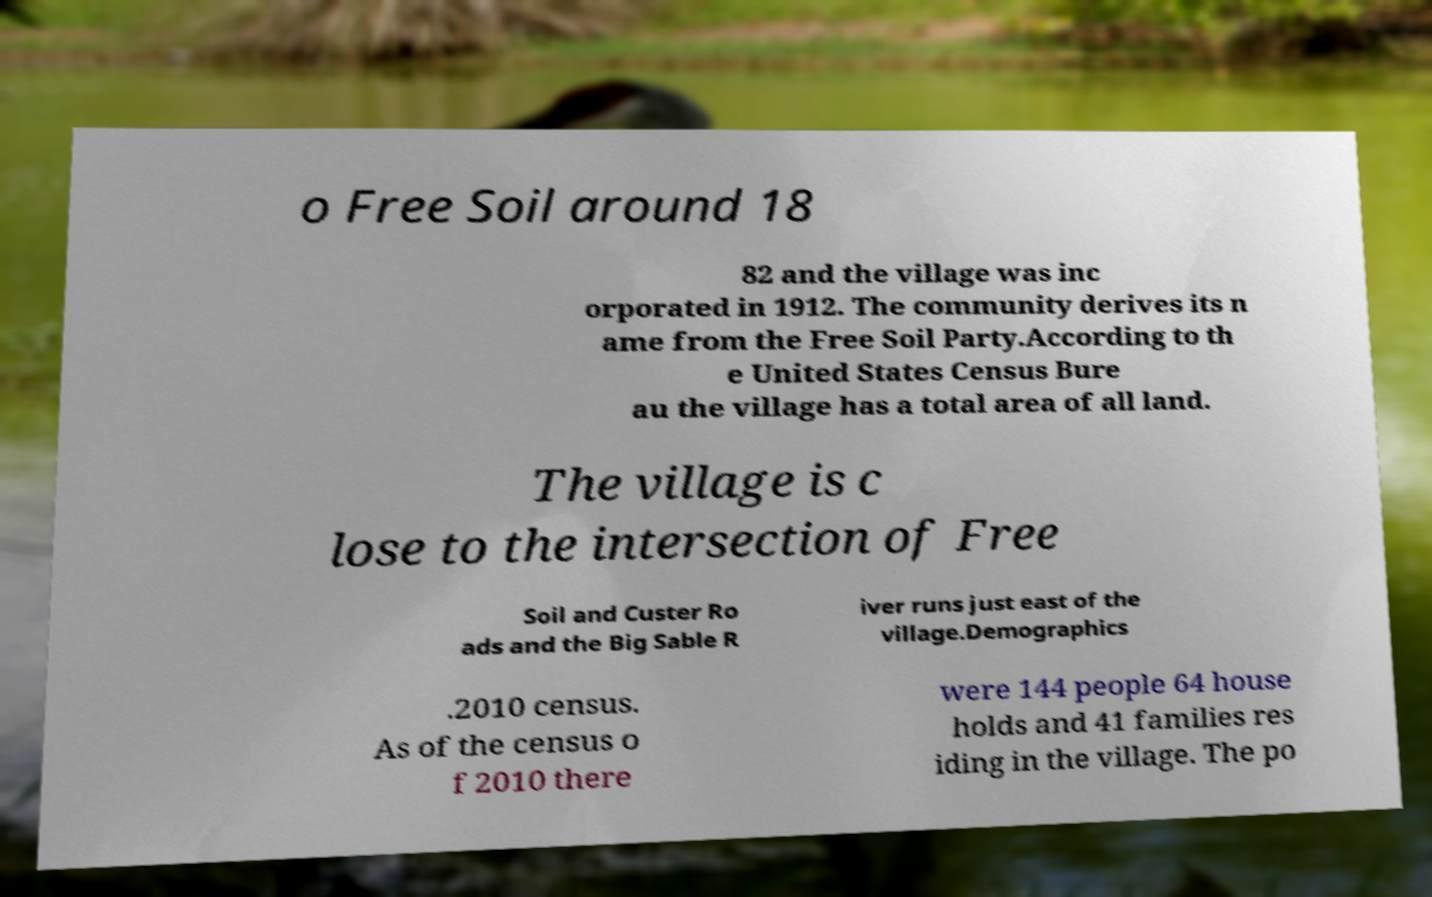What messages or text are displayed in this image? I need them in a readable, typed format. o Free Soil around 18 82 and the village was inc orporated in 1912. The community derives its n ame from the Free Soil Party.According to th e United States Census Bure au the village has a total area of all land. The village is c lose to the intersection of Free Soil and Custer Ro ads and the Big Sable R iver runs just east of the village.Demographics .2010 census. As of the census o f 2010 there were 144 people 64 house holds and 41 families res iding in the village. The po 